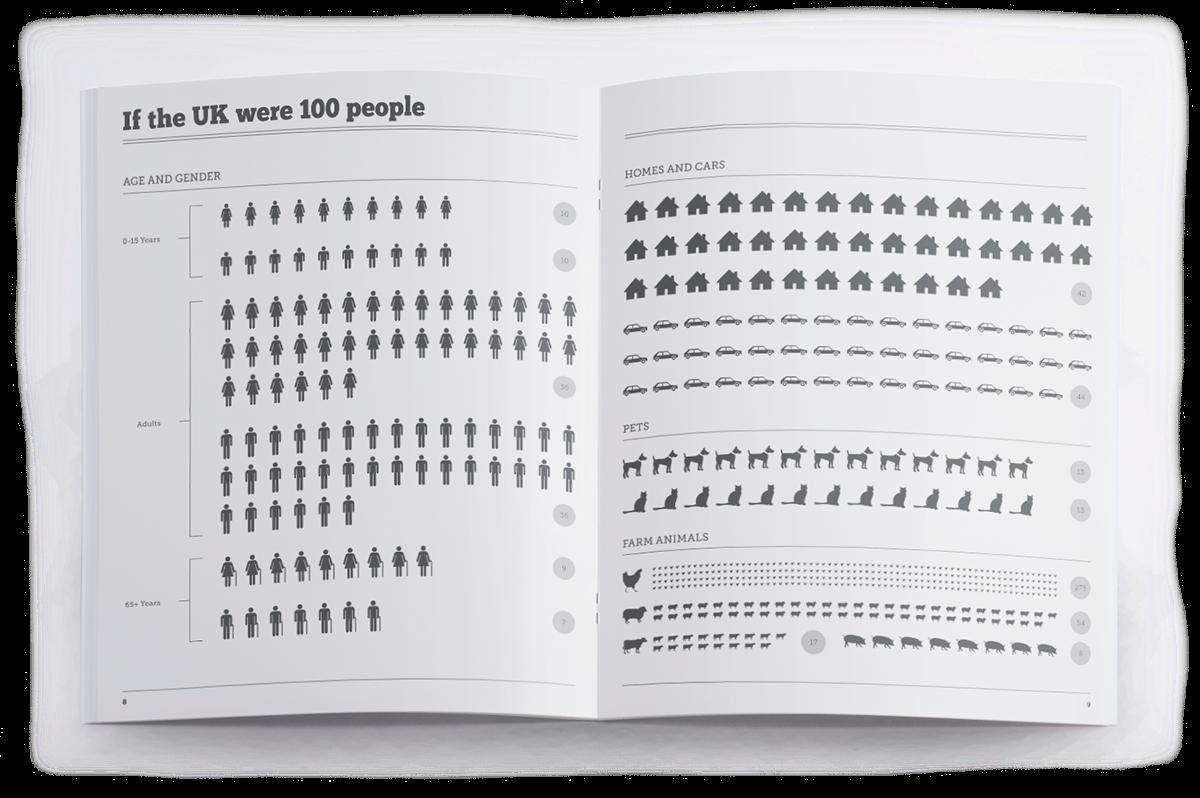What is the number of boys in the group of 20 children aged 0-15, of which 10 are girls ?
Answer the question with a short phrase. 10 Calculate the number adult women, from a total of 72 adults of which 36 are men? 36 What is the total number of pets ? 26 What is the total of number of senior citizens in the UK? 16 What is the total number of cows and pigs in farm animals? 25 